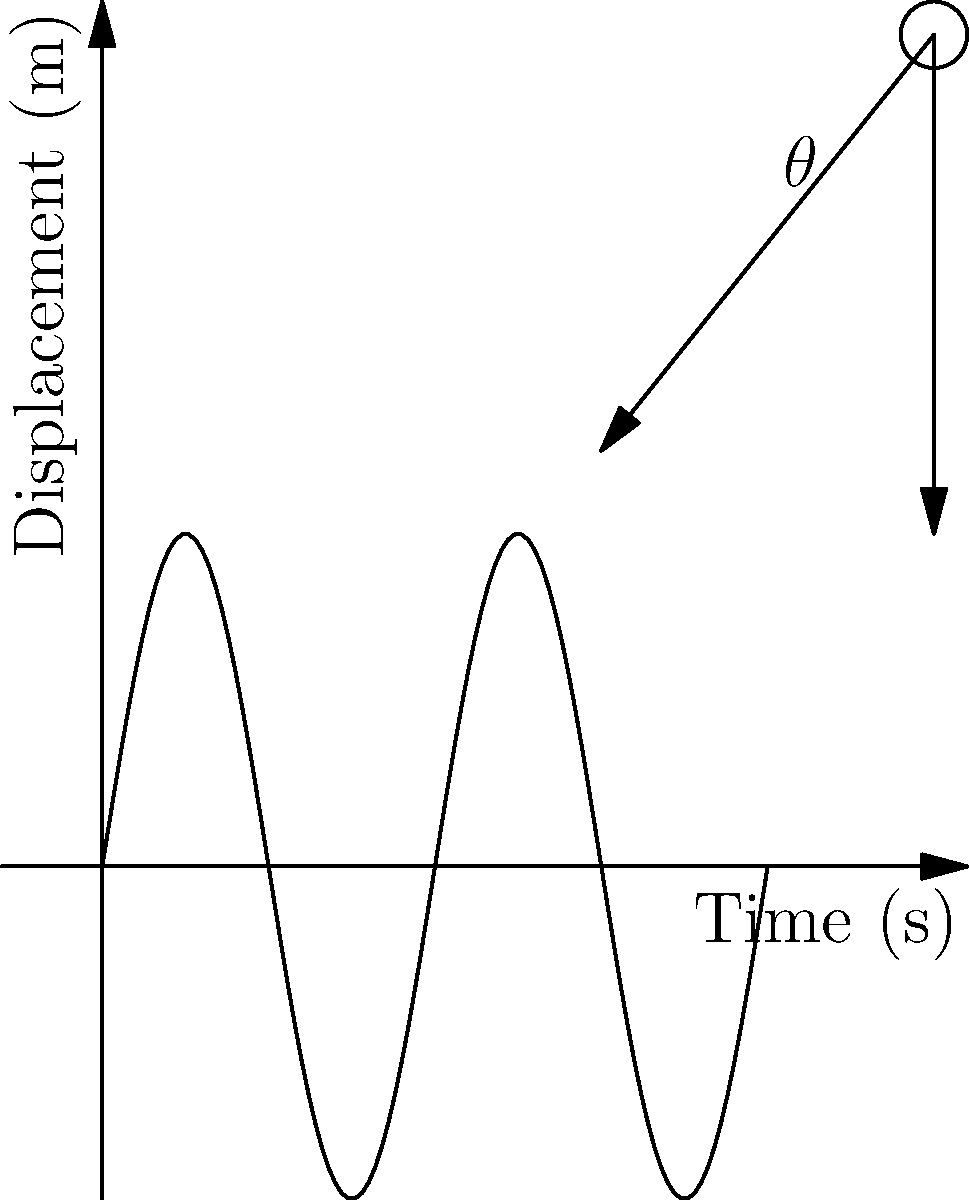As a language policy advocate, you're explaining the concept of simple harmonic motion to a group of students from diverse linguistic backgrounds. Using the pendulum diagram and time-displacement graph, explain how the motion of a pendulum relates to linguistic diversity in your region. What is the period of the oscillation shown in the graph, and how might this concept be used to analyze speech patterns across different languages? Let's break this down step-by-step:

1. The pendulum diagram shows a simple pendulum, which undergoes simple harmonic motion. This motion is analogous to the ebb and flow of language use in a diverse linguistic landscape.

2. The time-displacement graph represents the motion of the pendulum over time. The sinusoidal wave shows how the displacement varies periodically, similar to how language usage might fluctuate in a multilingual community.

3. To find the period of oscillation, we need to determine the time for one complete cycle. From the graph, we can see that one complete cycle occurs from t = 0 to t = 2 seconds.

4. The period (T) is thus 2 seconds. Mathematically, we can express this as:

   $$T = 2\text{ s}$$

5. In the context of linguistic diversity, this period could represent the time frame for observing language usage patterns or the cycle of language policy implementation and evaluation.

6. The amplitude of the oscillation (2 meters) could represent the extent of linguistic diversity or the intensity of language policy effects.

7. In analyzing speech patterns, the frequency of the oscillation (f = 1/T = 0.5 Hz) could be related to the rate of code-switching or the frequency of certain phonetic features across languages.

8. The phase of the oscillation could represent the current state of a language within the linguistic ecosystem of the region.

This analogy allows us to quantify and visualize aspects of linguistic diversity, providing a scientific framework for language policy discussions.
Answer: 2 seconds 